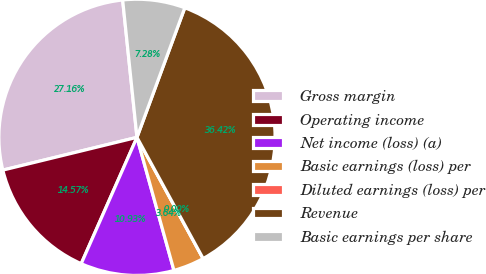<chart> <loc_0><loc_0><loc_500><loc_500><pie_chart><fcel>Gross margin<fcel>Operating income<fcel>Net income (loss) (a)<fcel>Basic earnings (loss) per<fcel>Diluted earnings (loss) per<fcel>Revenue<fcel>Basic earnings per share<nl><fcel>27.16%<fcel>14.57%<fcel>10.93%<fcel>3.64%<fcel>0.0%<fcel>36.42%<fcel>7.28%<nl></chart> 